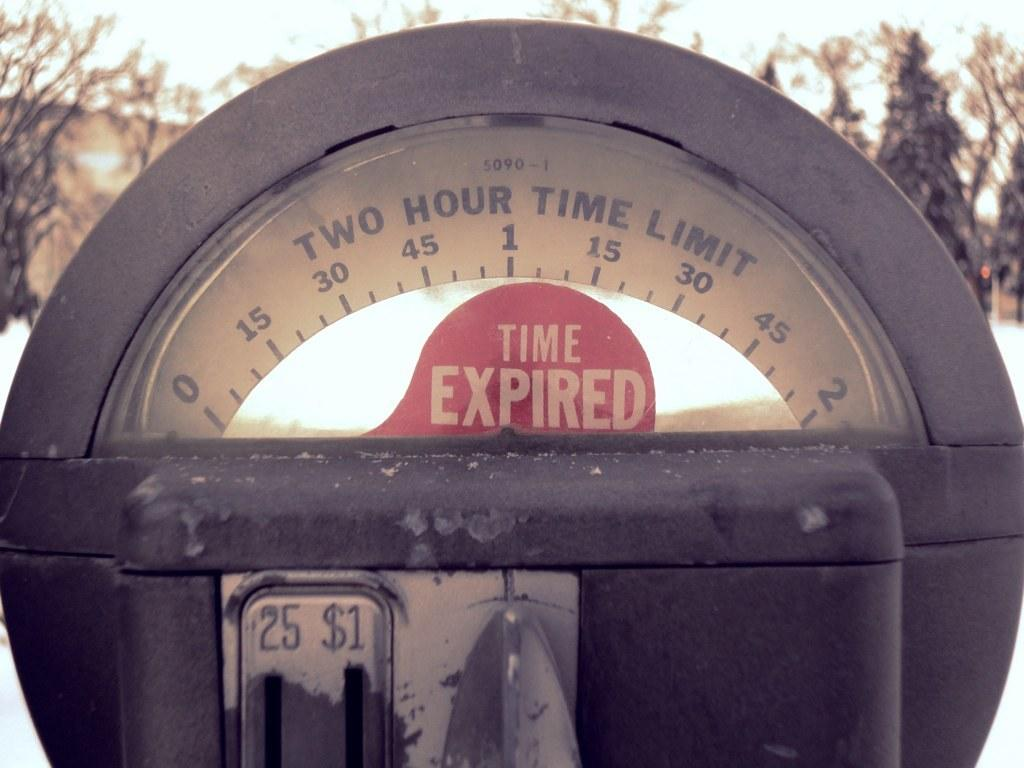<image>
Summarize the visual content of the image. Parketing meter that has a red sign that says Time expired. 